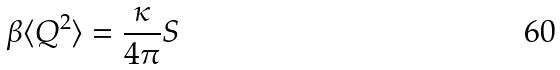Convert formula to latex. <formula><loc_0><loc_0><loc_500><loc_500>\beta \langle Q ^ { 2 } \rangle = \frac { \kappa } { 4 \pi } S</formula> 